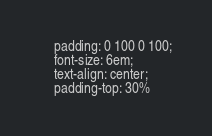<code> <loc_0><loc_0><loc_500><loc_500><_CSS_>    padding: 0 100 0 100;
    font-size: 6em;
    text-align: center;
    padding-top: 30%
</code> 